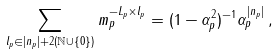<formula> <loc_0><loc_0><loc_500><loc_500>\sum _ { l _ { p } \in | n _ { p } | + 2 ( { \mathbb { N } } \cup \{ 0 \} ) } m _ { p } ^ { - L _ { p } \times l _ { p } } = ( 1 - \alpha _ { p } ^ { 2 } ) ^ { - 1 } \alpha _ { p } ^ { | n _ { p } | } \, ,</formula> 